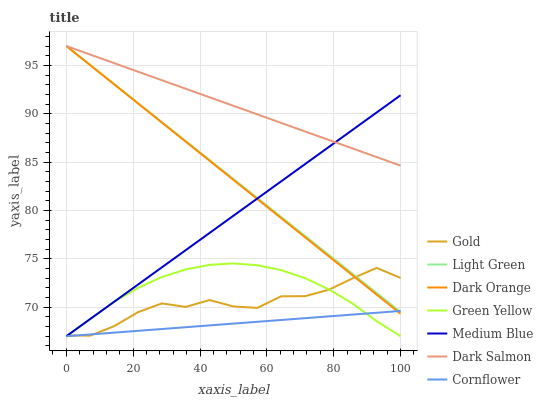Does Gold have the minimum area under the curve?
Answer yes or no. No. Does Gold have the maximum area under the curve?
Answer yes or no. No. Is Cornflower the smoothest?
Answer yes or no. No. Is Cornflower the roughest?
Answer yes or no. No. Does Gold have the lowest value?
Answer yes or no. No. Does Gold have the highest value?
Answer yes or no. No. Is Green Yellow less than Dark Orange?
Answer yes or no. Yes. Is Dark Salmon greater than Cornflower?
Answer yes or no. Yes. Does Green Yellow intersect Dark Orange?
Answer yes or no. No. 